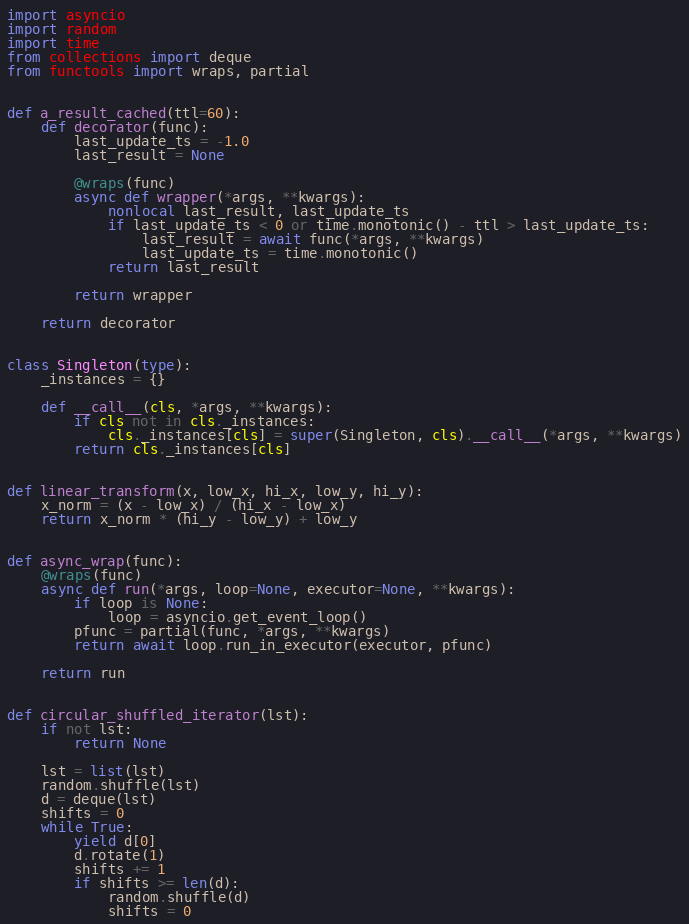Convert code to text. <code><loc_0><loc_0><loc_500><loc_500><_Python_>import asyncio
import random
import time
from collections import deque
from functools import wraps, partial


def a_result_cached(ttl=60):
    def decorator(func):
        last_update_ts = -1.0
        last_result = None

        @wraps(func)
        async def wrapper(*args, **kwargs):
            nonlocal last_result, last_update_ts
            if last_update_ts < 0 or time.monotonic() - ttl > last_update_ts:
                last_result = await func(*args, **kwargs)
                last_update_ts = time.monotonic()
            return last_result

        return wrapper

    return decorator


class Singleton(type):
    _instances = {}

    def __call__(cls, *args, **kwargs):
        if cls not in cls._instances:
            cls._instances[cls] = super(Singleton, cls).__call__(*args, **kwargs)
        return cls._instances[cls]


def linear_transform(x, low_x, hi_x, low_y, hi_y):
    x_norm = (x - low_x) / (hi_x - low_x)
    return x_norm * (hi_y - low_y) + low_y


def async_wrap(func):
    @wraps(func)
    async def run(*args, loop=None, executor=None, **kwargs):
        if loop is None:
            loop = asyncio.get_event_loop()
        pfunc = partial(func, *args, **kwargs)
        return await loop.run_in_executor(executor, pfunc)

    return run


def circular_shuffled_iterator(lst):
    if not lst:
        return None

    lst = list(lst)
    random.shuffle(lst)
    d = deque(lst)
    shifts = 0
    while True:
        yield d[0]
        d.rotate(1)
        shifts += 1
        if shifts >= len(d):
            random.shuffle(d)
            shifts = 0
</code> 